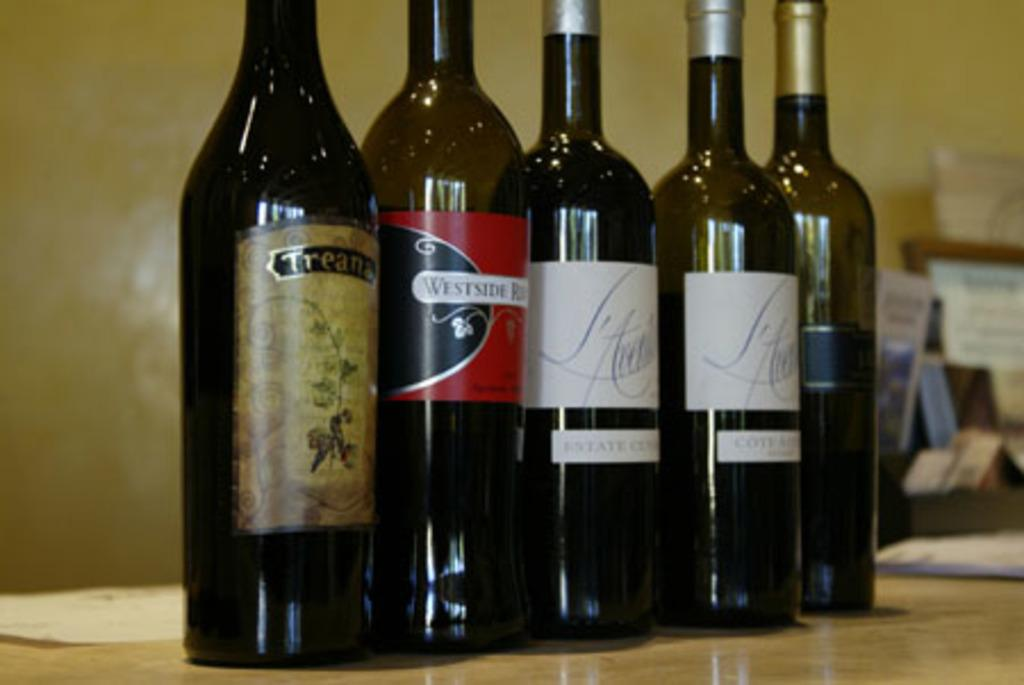<image>
Describe the image concisely. Four choices of wine bottles with one from Westside 